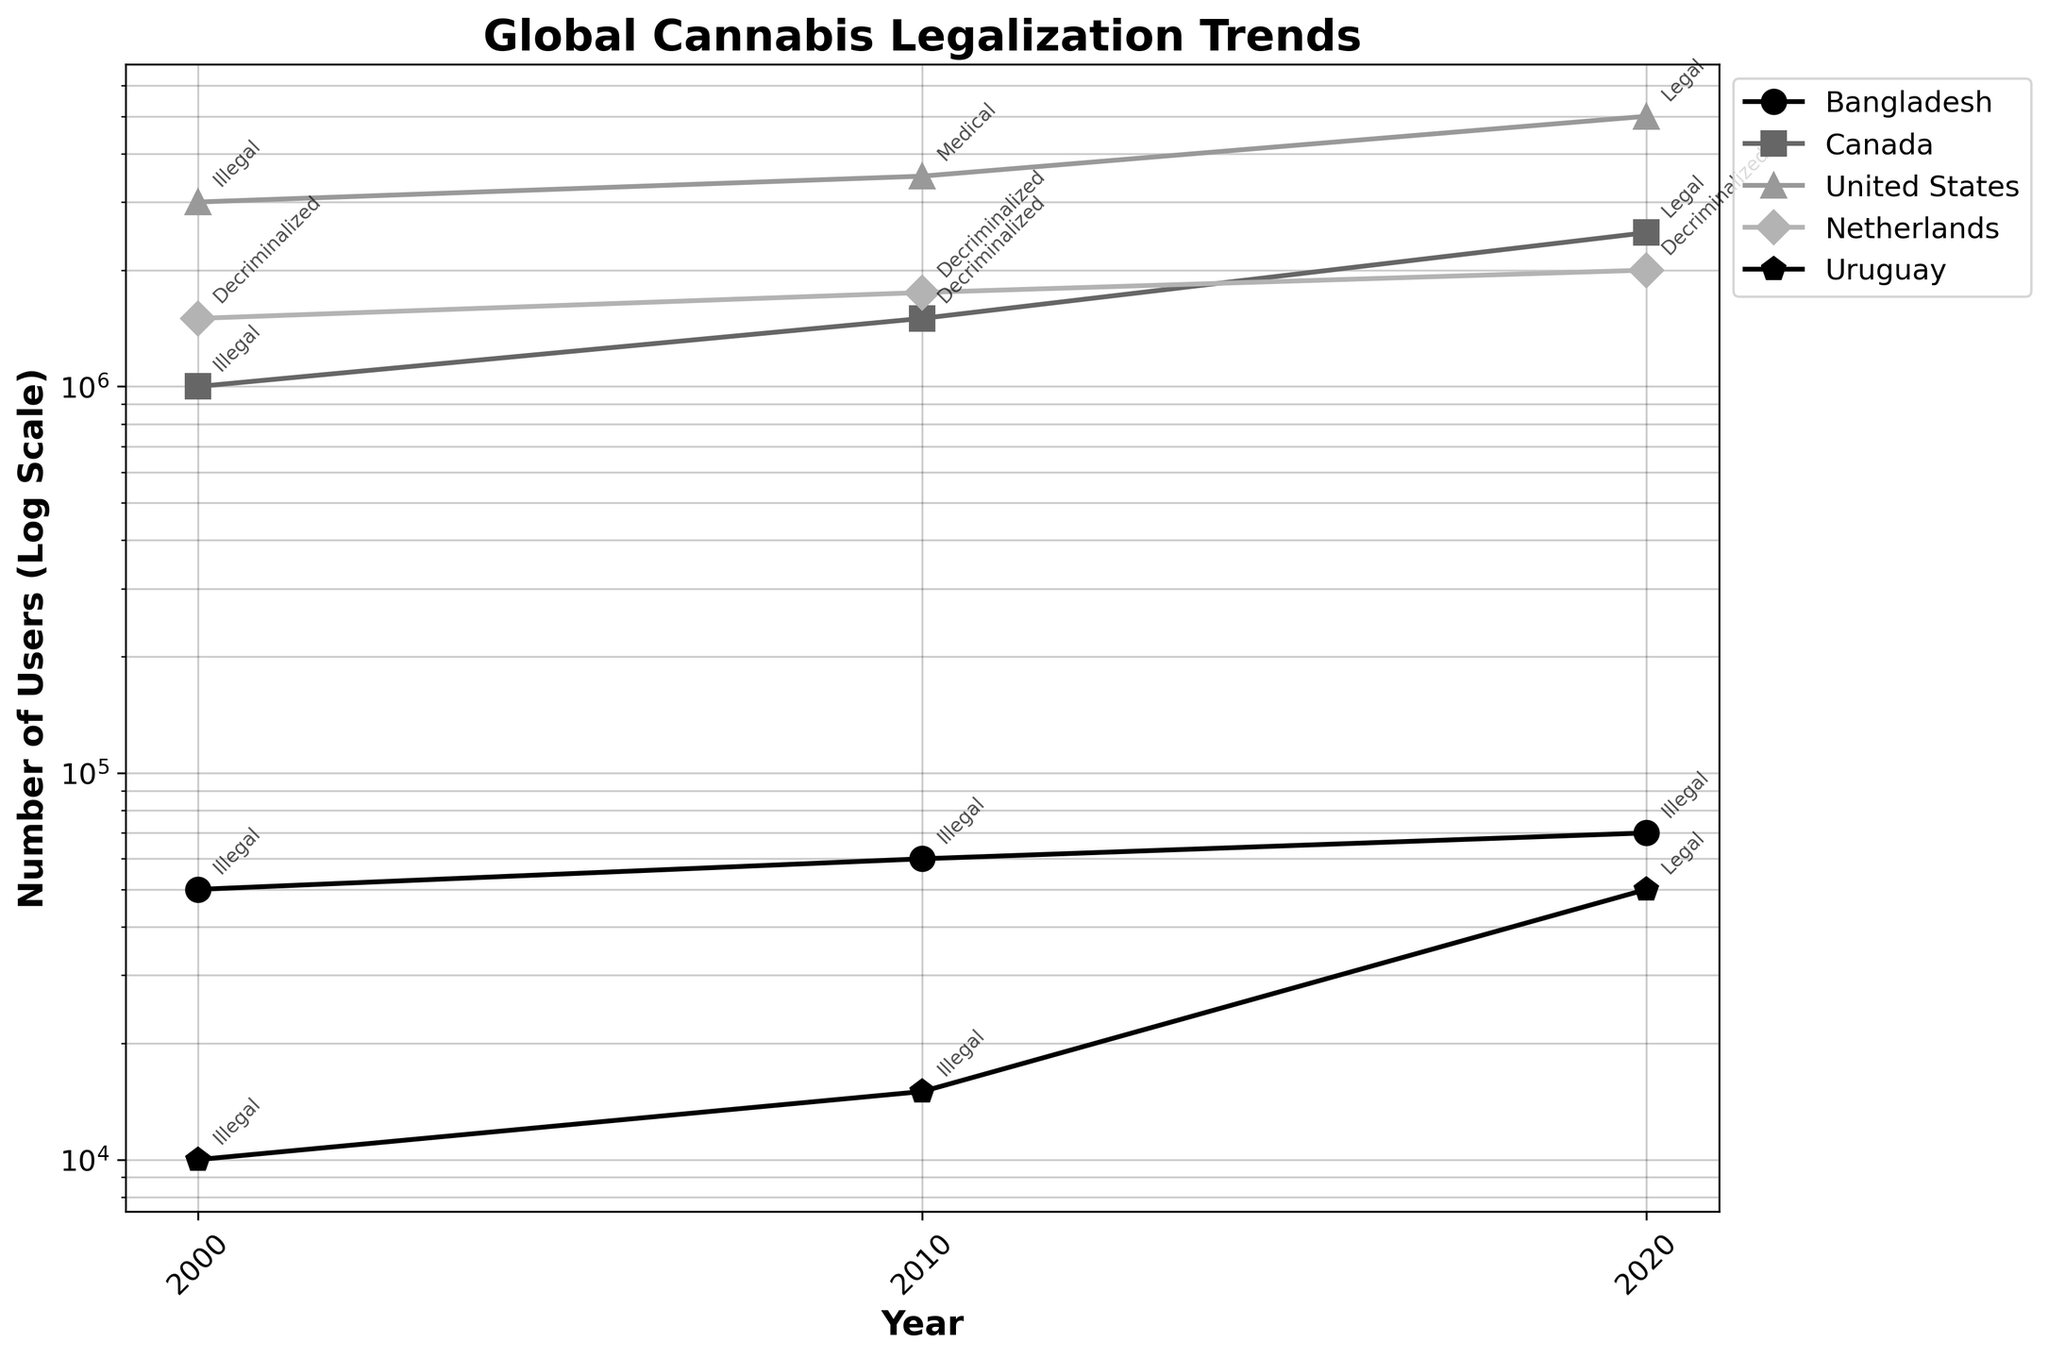What is the title of the plot? The title of the plot contains the information at the top and summarizes what the entire plot is about. In this case, it is explicitly written there.
Answer: Global Cannabis Legalization Trends How many countries are represented in the plot? Each line in the plot represents a different country, and the legend on the right side of the plot lists all the countries represented by different colored and shaped markers. Count the number of different countries listed in the legend.
Answer: 5 Which country had the highest increase in the number of users from 2000 to 2020? To determine the increase in users, look at the end (2020) and the start (2000) of each country's line on the log scale. The country with the largest difference between these two points will have the highest increase.
Answer: United States What is the status of cannabis in Canada in 2020? Alongside the number of users on the log scale, each point is annotated with the current legal status of cannabis in that country and year. For Canada in 2020, check the annotation near the data point.
Answer: Legal How does the number of users in Bangladesh in 2020 compare to that in Uruguay in 2020? Identify the points for Bangladesh and Uruguay in 2020 and read the number of users from the log scale on the y-axis. Compare these values to determine which is higher.
Answer: Higher in Bangladesh Which country has the number of users consistently increasing across all years? Analyze the trend lines for each country to see which one shows a consistent upward trend from 2000 to 2020.
Answer: United States How does the legalization status of the Netherlands compare to Bangladesh across the observed years? Check the annotations along the data points for both the Netherlands and Bangladesh across the years 2000, 2010, and 2020 to see the legal status mentioned.
Answer: Netherlands: Decriminalized, Bangladesh: Illegal What was the status of cannabis in the United States in 2010 and how many users were there then? Find the 2010 marker for the United States line and read the status annotation. Also, read the number of users from the y-axis.
Answer: Medical, 3,500,000 Did any country have a decrease in the number of users from 2010 to 2020? Look at the trend lines for each country between the points of 2010 and 2020, and see if any lines decrease over this period.
Answer: No Which country experienced the introduction of legalization between 2010 and 2020, and how many users did it have in 2020? Find the countries where the status changes to “Legal” in 2020, which means legalization was introduced between 2010 to 2020. Look at Uruguay’s data.
Answer: Uruguay, 50,000 